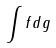Convert formula to latex. <formula><loc_0><loc_0><loc_500><loc_500>\int f d g</formula> 